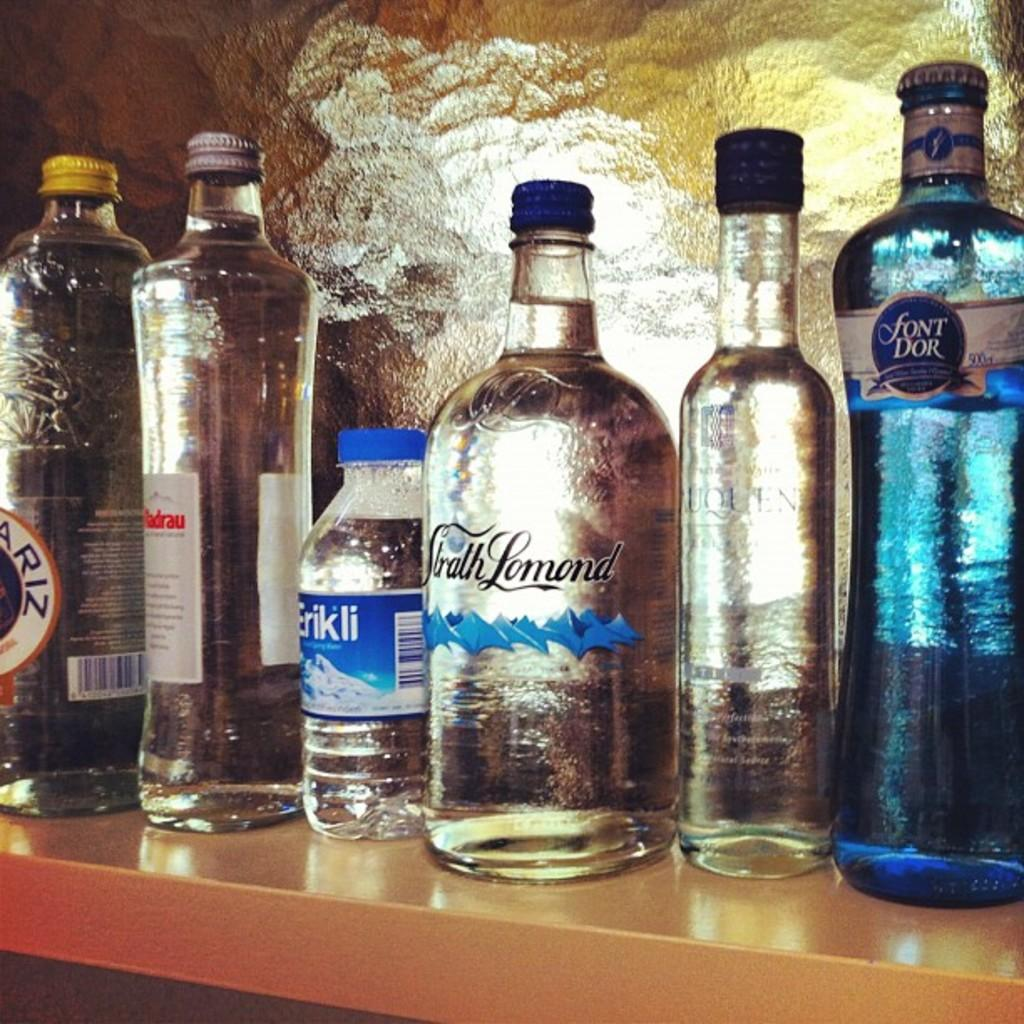<image>
Give a short and clear explanation of the subsequent image. Several bottles of drink, one of which has Font Dor on the label. 